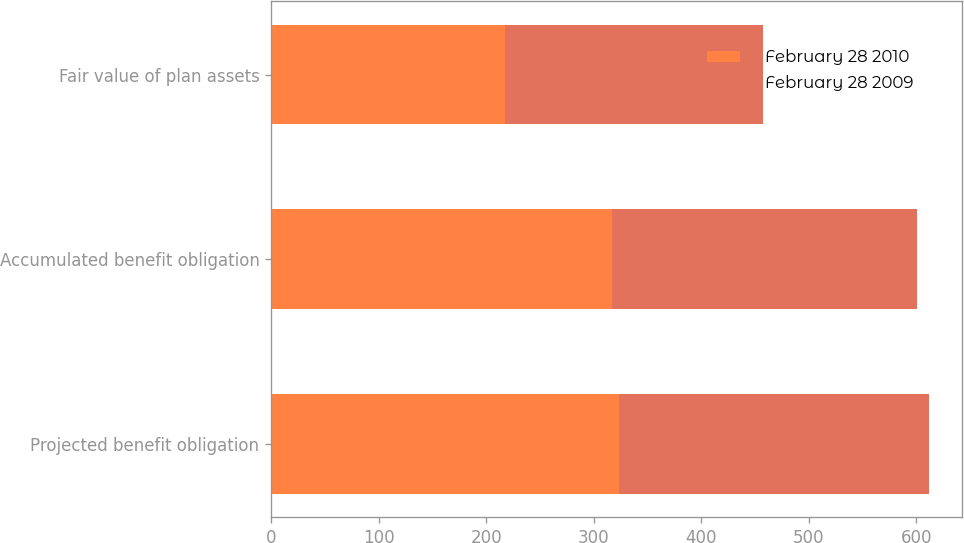Convert chart to OTSL. <chart><loc_0><loc_0><loc_500><loc_500><stacked_bar_chart><ecel><fcel>Projected benefit obligation<fcel>Accumulated benefit obligation<fcel>Fair value of plan assets<nl><fcel>February 28 2010<fcel>323.2<fcel>317.2<fcel>217.6<nl><fcel>February 28 2009<fcel>288.8<fcel>283.1<fcel>240.1<nl></chart> 